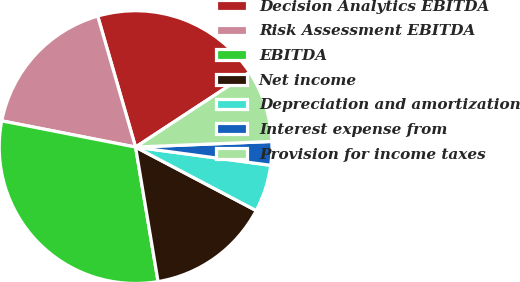Convert chart to OTSL. <chart><loc_0><loc_0><loc_500><loc_500><pie_chart><fcel>Decision Analytics EBITDA<fcel>Risk Assessment EBITDA<fcel>EBITDA<fcel>Net income<fcel>Depreciation and amortization<fcel>Interest expense from<fcel>Provision for income taxes<nl><fcel>20.23%<fcel>17.44%<fcel>30.72%<fcel>14.65%<fcel>5.58%<fcel>2.79%<fcel>8.59%<nl></chart> 